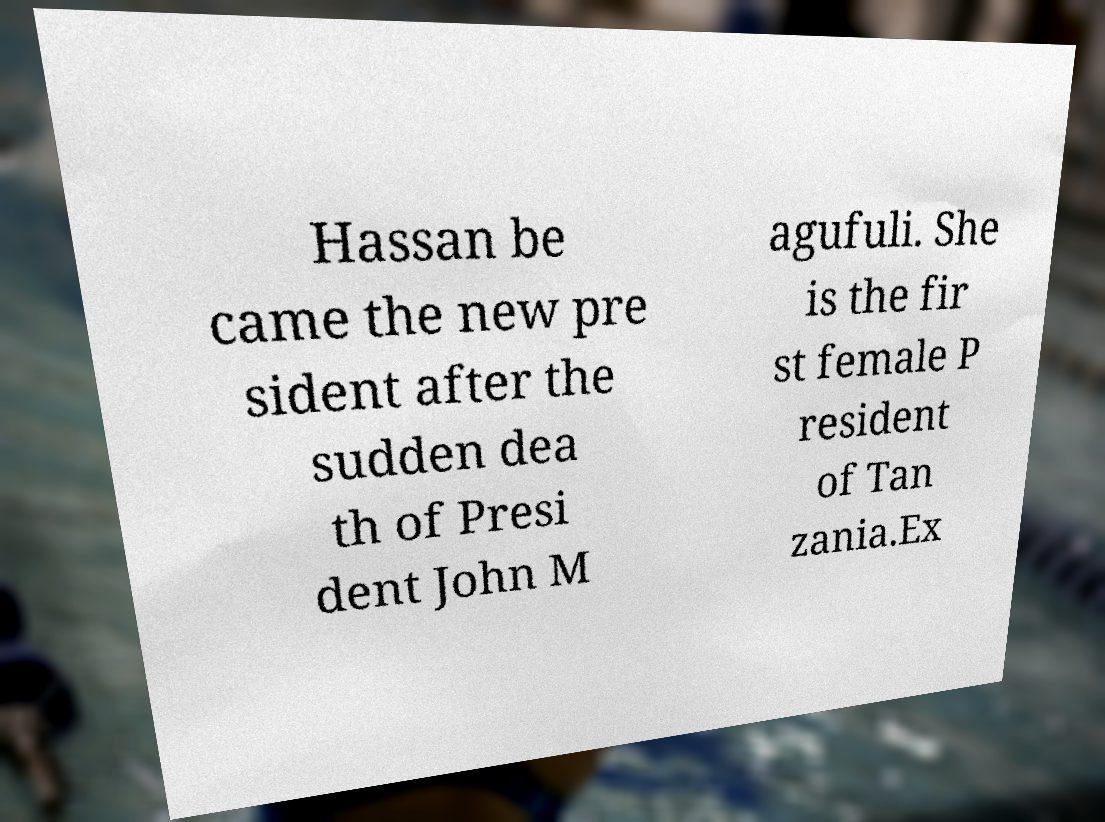Can you accurately transcribe the text from the provided image for me? Hassan be came the new pre sident after the sudden dea th of Presi dent John M agufuli. She is the fir st female P resident of Tan zania.Ex 